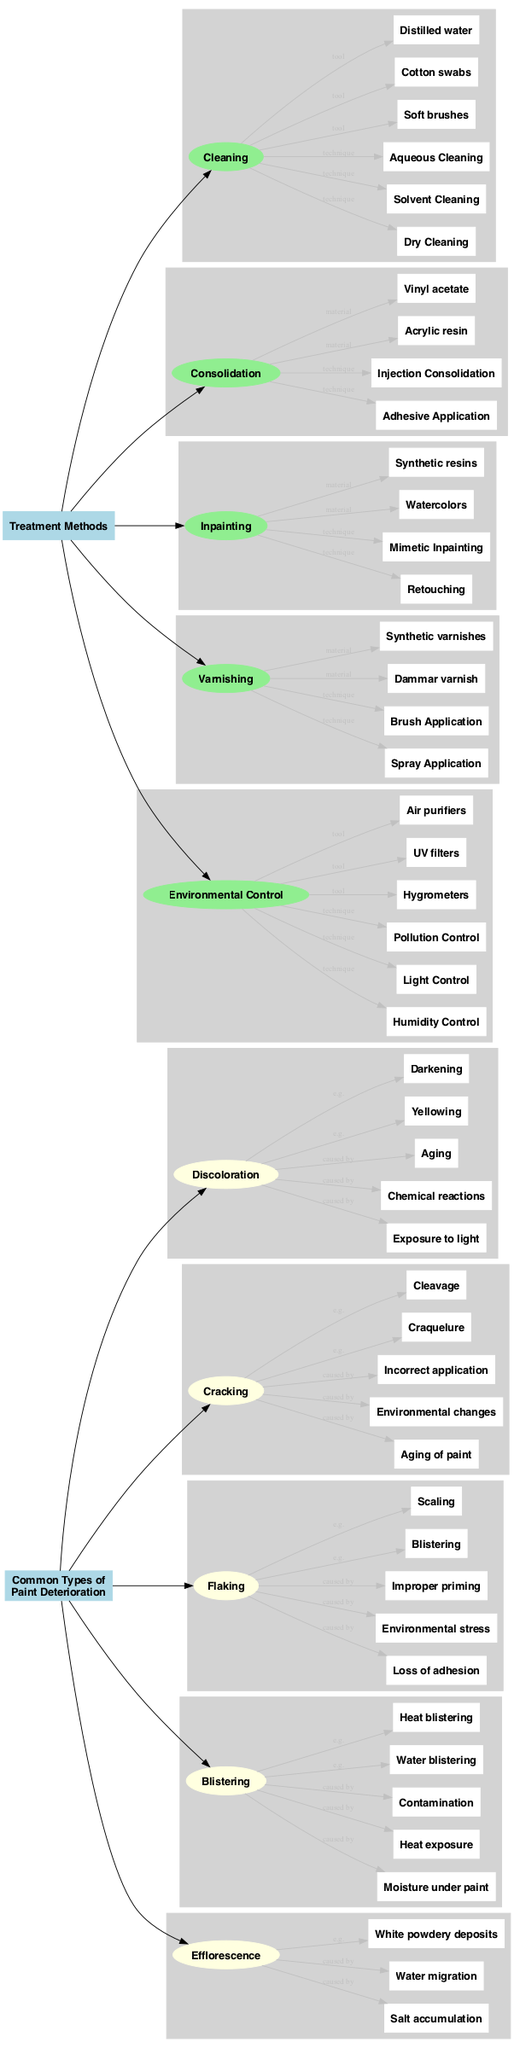What are the common types of paint deterioration? The diagram shows five subcategories under the section "Common Types of Paint Deterioration", which are Discoloration, Cracking, Flaking, Blistering, and Efflorescence.
Answer: Discoloration, Cracking, Flaking, Blistering, Efflorescence How many treatment methods are listed in the diagram? The diagram includes five methods listed under "Treatment Methods", which are Cleaning, Consolidation, Inpainting, Varnishing, and Environmental Control. Counting them gives us a total of five.
Answer: 5 What causes discoloration in paint? The subcategory "Discoloration" lists three causes: Exposure to light, Chemical reactions, and Aging.
Answer: Exposure to light, Chemical reactions, Aging Which method uses watercolors as a material? The diagram indicates that "Inpainting" is the method that lists watercolors as one of its materials.
Answer: Inpainting What is one example of blistering? Under the "Blistering" subcategory, one example listed is "Water blistering".
Answer: Water blistering What types of techniques are used in the cleaning method? The "Cleaning" method shows three techniques: Dry Cleaning, Solvent Cleaning, and Aqueous Cleaning listed.
Answer: Dry Cleaning, Solvent Cleaning, Aqueous Cleaning How does cracking occur due to environmental changes? The "Cracking" subcategory lists "Environmental changes" as one of the causes. This indicates that shifts in environmental conditions can lead to cracking paint layers.
Answer: Environmental changes What is the relationship between Consolidation and materials? The method "Consolidation" is directly connected to two materials: Acrylic resin and Vinyl acetate, indicating that these materials are used in this treatment method.
Answer: Acrylic resin, Vinyl acetate What techniques are associated with environmental control? The "Environmental Control" method lists three techniques: Humidity Control, Light Control, and Pollution Control, showing how different environmental factors can be managed.
Answer: Humidity Control, Light Control, Pollution Control 